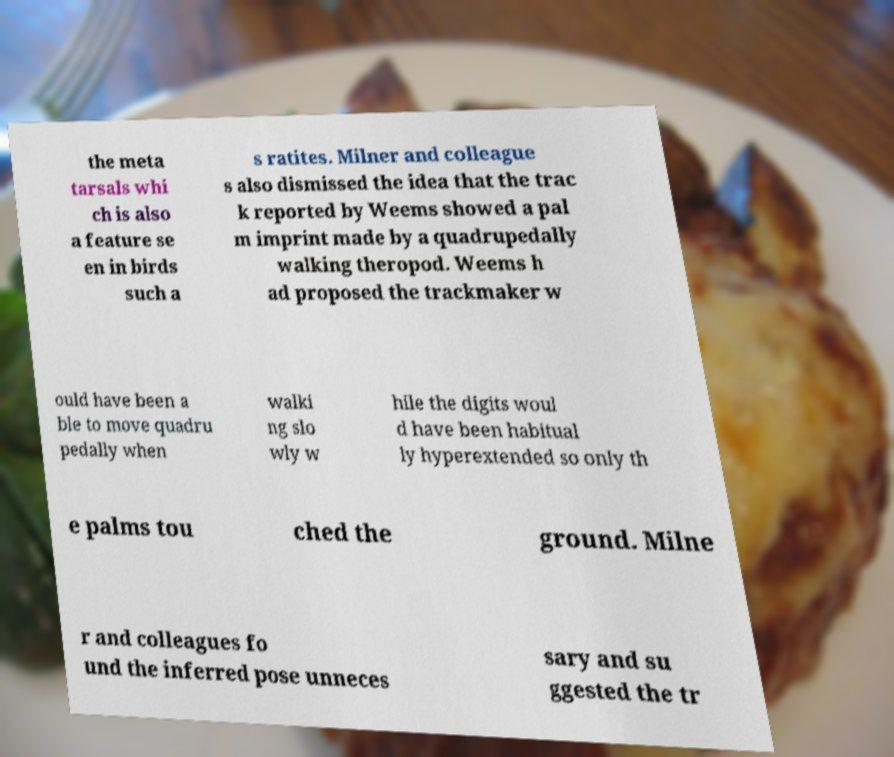Can you read and provide the text displayed in the image?This photo seems to have some interesting text. Can you extract and type it out for me? the meta tarsals whi ch is also a feature se en in birds such a s ratites. Milner and colleague s also dismissed the idea that the trac k reported by Weems showed a pal m imprint made by a quadrupedally walking theropod. Weems h ad proposed the trackmaker w ould have been a ble to move quadru pedally when walki ng slo wly w hile the digits woul d have been habitual ly hyperextended so only th e palms tou ched the ground. Milne r and colleagues fo und the inferred pose unneces sary and su ggested the tr 